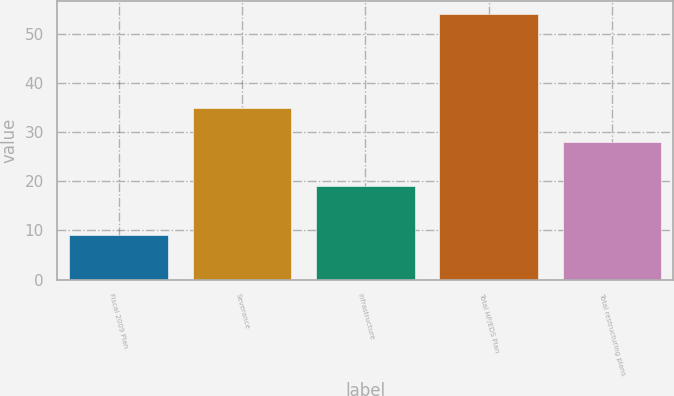<chart> <loc_0><loc_0><loc_500><loc_500><bar_chart><fcel>Fiscal 2009 Plan<fcel>Severance<fcel>Infrastructure<fcel>Total HP/EDS Plan<fcel>Total restructuring plans<nl><fcel>9<fcel>35<fcel>19<fcel>54<fcel>28<nl></chart> 